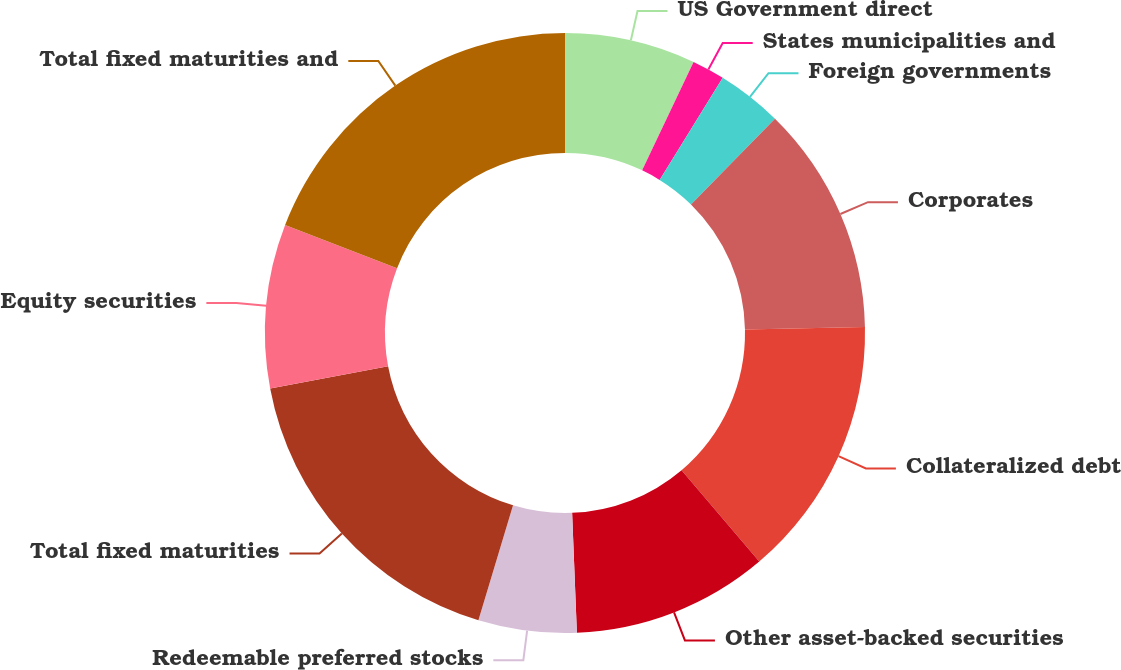Convert chart. <chart><loc_0><loc_0><loc_500><loc_500><pie_chart><fcel>US Government direct<fcel>States municipalities and<fcel>Foreign governments<fcel>Corporates<fcel>Collateralized debt<fcel>Other asset-backed securities<fcel>Redeemable preferred stocks<fcel>Total fixed maturities<fcel>Equity securities<fcel>Total fixed maturities and<nl><fcel>7.05%<fcel>1.76%<fcel>3.53%<fcel>12.34%<fcel>14.11%<fcel>10.58%<fcel>5.29%<fcel>17.38%<fcel>8.82%<fcel>19.14%<nl></chart> 